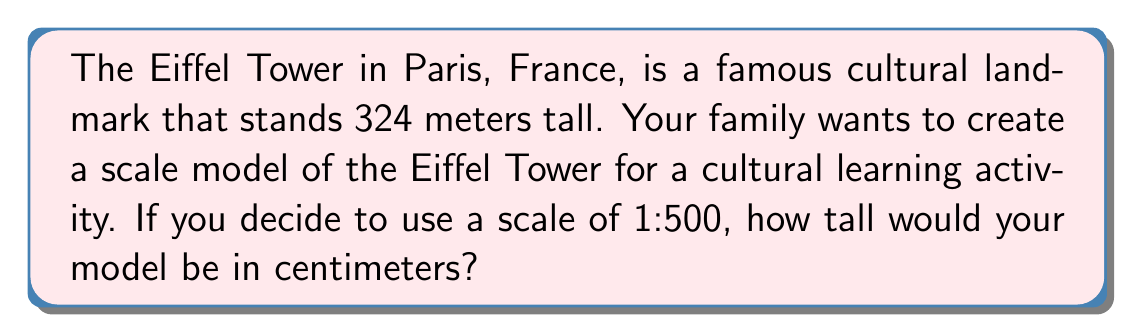Show me your answer to this math problem. To solve this problem, we need to follow these steps:

1. Understand the scale:
   A scale of 1:500 means that 1 unit on the model represents 500 units on the actual structure.

2. Convert the actual height to the same unit as the scale:
   The Eiffel Tower is 324 meters tall.
   $324 \text{ meters} = 32400 \text{ centimeters}$

3. Apply the scale to find the model height:
   Let $x$ be the height of the model in centimeters.
   We can set up the following proportion:
   $$\frac{x}{32400} = \frac{1}{500}$$

4. Solve for $x$:
   $$x = \frac{32400}{500} = 64.8 \text{ cm}$$

Therefore, the scale model of the Eiffel Tower would be 64.8 cm tall.
Answer: 64.8 cm 